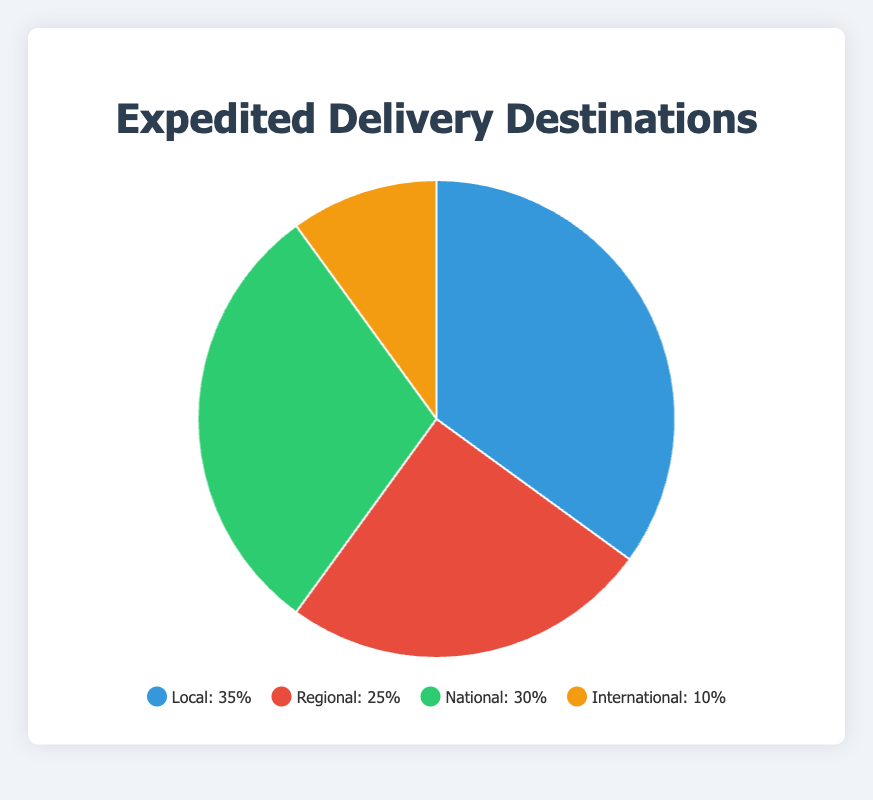What's the largest delivery category? To determine the largest delivery category, we look at the percentages for each category. The category 'Local' has the highest percentage at 35%.
Answer: Local Which area receives the least deliveries? To find the area that receives the least deliveries, we compare all the given percentages. 'International' has the smallest percentage at 10%.
Answer: International How much more percentage does 'Regional' have over 'International'? Subtract the percentage of 'International' from 'Regional': 25% - 10% = 15%.
Answer: 15% What is the sum of 'Local' and 'National' deliveries? Add the percentages of 'Local' and 'National': 35% + 30% = 65%.
Answer: 65% What delivery category is represented by the green color? By checking the color representation in the legend, the green color corresponds to the 'National' category (30%).
Answer: National How does the percentage for 'Local' deliveries compare to 'National' deliveries? Compare the percentages: the 'Local' category has 35% while 'National' has 30%. Therefore, 'Local' has a higher percentage.
Answer: Higher If you combine 'Regional' and 'International', what percentage of deliveries do you get? Add the percentages of 'Regional' and 'International': 25% + 10% = 35%.
Answer: 35% Is 'International' deliveries percentage less than half of 'Local' deliveries? Check if the percentage of 'International' (10%) is less than half of 'Local' (35%). Half of 'Local' is 17.5%. Since 10% < 17.5%, the statement is true.
Answer: Yes What is the difference in delivery percentages between 'National' and the sum of 'Regional' and 'International'? First, sum up 'Regional' and 'International': 25% + 10% = 35%. Then, subtract 'National' from this sum: 35% - 30% = 5%.
Answer: 5% 